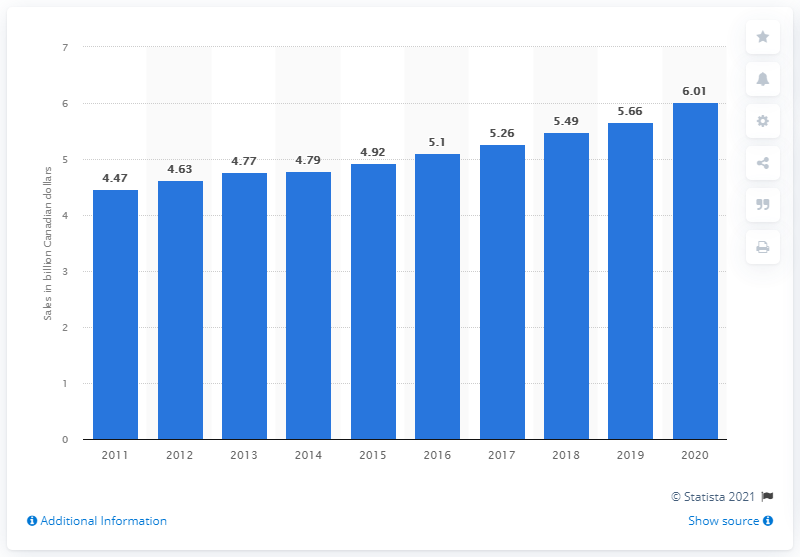Draw attention to some important aspects in this diagram. The sales value of spirits in Canada in 2011 was CAD 5.66 billion. 